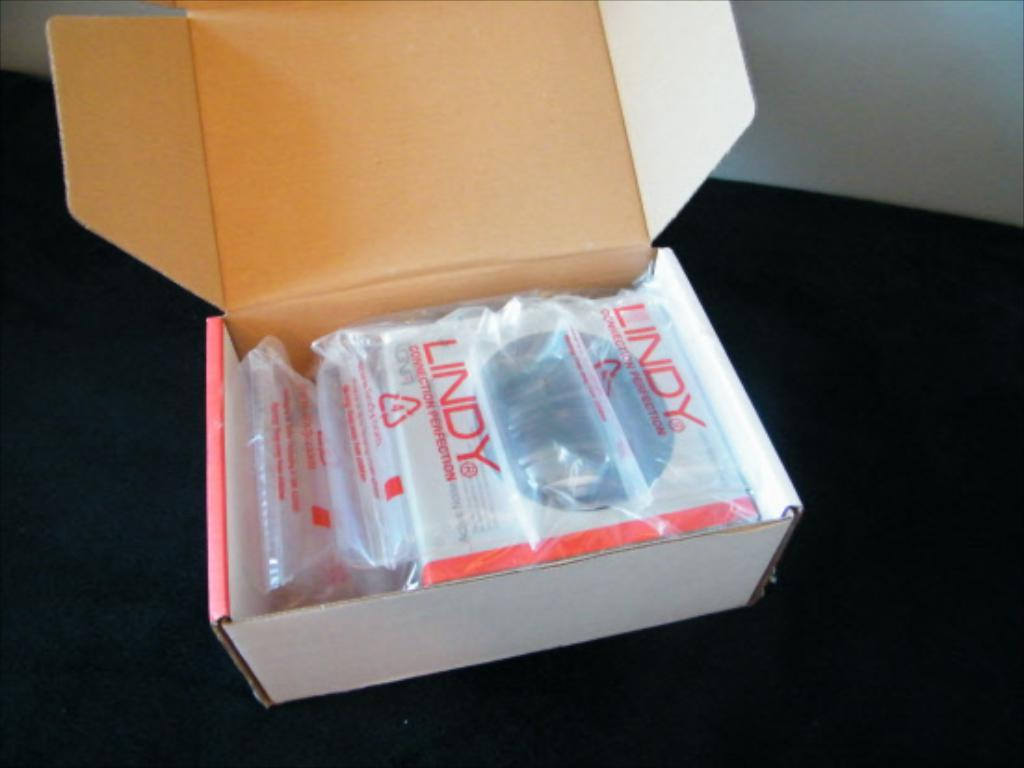Provide a one-sentence caption for the provided image. A white box with plastic wrap that says Lindy. 